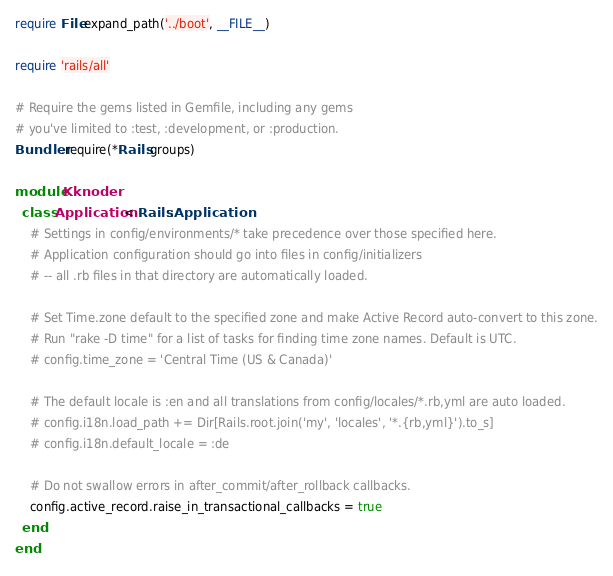Convert code to text. <code><loc_0><loc_0><loc_500><loc_500><_Ruby_>require File.expand_path('../boot', __FILE__)

require 'rails/all'

# Require the gems listed in Gemfile, including any gems
# you've limited to :test, :development, or :production.
Bundler.require(*Rails.groups)

module Kknoder
  class Application < Rails::Application
    # Settings in config/environments/* take precedence over those specified here.
    # Application configuration should go into files in config/initializers
    # -- all .rb files in that directory are automatically loaded.

    # Set Time.zone default to the specified zone and make Active Record auto-convert to this zone.
    # Run "rake -D time" for a list of tasks for finding time zone names. Default is UTC.
    # config.time_zone = 'Central Time (US & Canada)'

    # The default locale is :en and all translations from config/locales/*.rb,yml are auto loaded.
    # config.i18n.load_path += Dir[Rails.root.join('my', 'locales', '*.{rb,yml}').to_s]
    # config.i18n.default_locale = :de

    # Do not swallow errors in after_commit/after_rollback callbacks.
    config.active_record.raise_in_transactional_callbacks = true
  end
end
</code> 